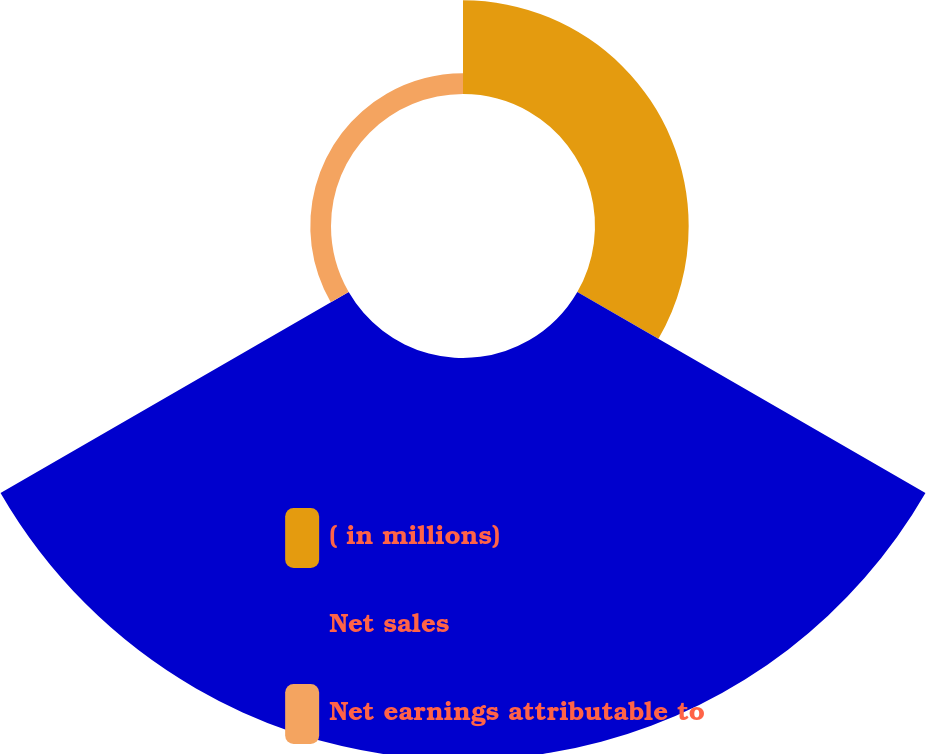Convert chart to OTSL. <chart><loc_0><loc_0><loc_500><loc_500><pie_chart><fcel>( in millions)<fcel>Net sales<fcel>Net earnings attributable to<nl><fcel>18.14%<fcel>77.85%<fcel>4.01%<nl></chart> 